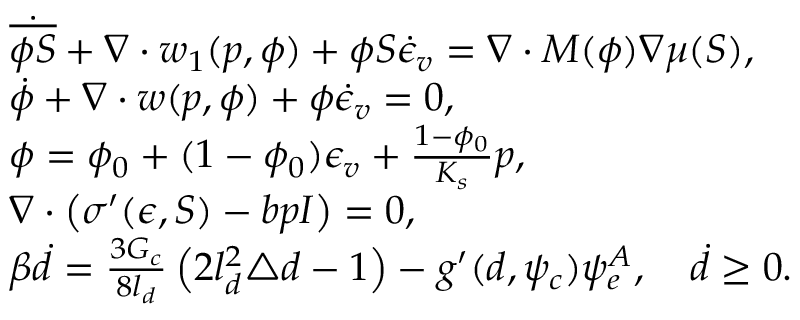<formula> <loc_0><loc_0><loc_500><loc_500>\begin{array} { r l } & { \dot { \overline { \phi S } } + \nabla \cdot w _ { 1 } ( p , \phi ) + \phi S \dot { \epsilon } _ { v } = \nabla \cdot M ( \phi ) \nabla \mu ( S ) , } \\ & { \dot { \phi } + \nabla \cdot w ( p , \phi ) + \phi \dot { \epsilon } _ { v } = 0 , } \\ & { \phi = \phi _ { 0 } + ( 1 - \phi _ { 0 } ) \epsilon _ { v } + \frac { 1 - \phi _ { 0 } } { K _ { s } } p , } \\ & { \nabla \cdot \left ( \sigma ^ { \prime } ( \epsilon , S ) - b p I \right ) = 0 , } \\ & { \beta \dot { d } = \frac { 3 G _ { c } } { 8 l _ { d } } \left ( 2 l _ { d } ^ { 2 } \triangle { d } - 1 \right ) - g ^ { \prime } ( d , \psi _ { c } ) \psi _ { e } ^ { A } , \quad \dot { d } \geq 0 . } \end{array}</formula> 